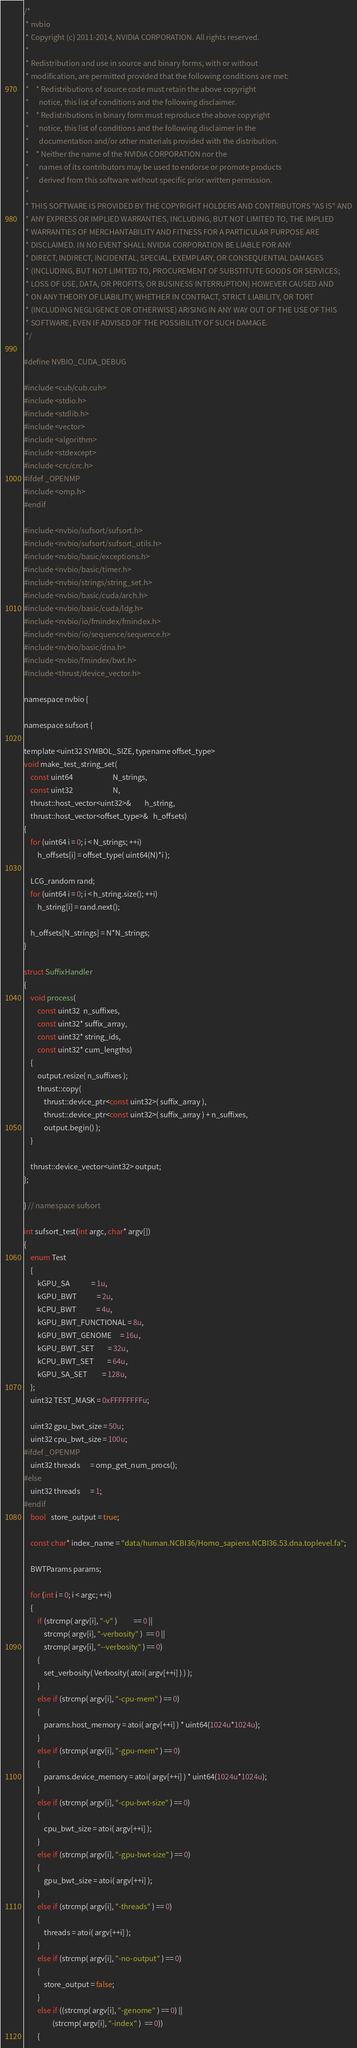Convert code to text. <code><loc_0><loc_0><loc_500><loc_500><_Cuda_>/*
 * nvbio
 * Copyright (c) 2011-2014, NVIDIA CORPORATION. All rights reserved.
 * 
 * Redistribution and use in source and binary forms, with or without
 * modification, are permitted provided that the following conditions are met:
 *    * Redistributions of source code must retain the above copyright
 *      notice, this list of conditions and the following disclaimer.
 *    * Redistributions in binary form must reproduce the above copyright
 *      notice, this list of conditions and the following disclaimer in the
 *      documentation and/or other materials provided with the distribution.
 *    * Neither the name of the NVIDIA CORPORATION nor the
 *      names of its contributors may be used to endorse or promote products
 *      derived from this software without specific prior written permission.
 * 
 * THIS SOFTWARE IS PROVIDED BY THE COPYRIGHT HOLDERS AND CONTRIBUTORS "AS IS" AND
 * ANY EXPRESS OR IMPLIED WARRANTIES, INCLUDING, BUT NOT LIMITED TO, THE IMPLIED
 * WARRANTIES OF MERCHANTABILITY AND FITNESS FOR A PARTICULAR PURPOSE ARE
 * DISCLAIMED. IN NO EVENT SHALL NVIDIA CORPORATION BE LIABLE FOR ANY
 * DIRECT, INDIRECT, INCIDENTAL, SPECIAL, EXEMPLARY, OR CONSEQUENTIAL DAMAGES
 * (INCLUDING, BUT NOT LIMITED TO, PROCUREMENT OF SUBSTITUTE GOODS OR SERVICES;
 * LOSS OF USE, DATA, OR PROFITS; OR BUSINESS INTERRUPTION) HOWEVER CAUSED AND
 * ON ANY THEORY OF LIABILITY, WHETHER IN CONTRACT, STRICT LIABILITY, OR TORT
 * (INCLUDING NEGLIGENCE OR OTHERWISE) ARISING IN ANY WAY OUT OF THE USE OF THIS
 * SOFTWARE, EVEN IF ADVISED OF THE POSSIBILITY OF SUCH DAMAGE.
 */

#define NVBIO_CUDA_DEBUG

#include <cub/cub.cuh>
#include <stdio.h>
#include <stdlib.h>
#include <vector>
#include <algorithm>
#include <stdexcept>
#include <crc/crc.h>
#ifdef _OPENMP
#include <omp.h>
#endif

#include <nvbio/sufsort/sufsort.h>
#include <nvbio/sufsort/sufsort_utils.h>
#include <nvbio/basic/exceptions.h>
#include <nvbio/basic/timer.h>
#include <nvbio/strings/string_set.h>
#include <nvbio/basic/cuda/arch.h>
#include <nvbio/basic/cuda/ldg.h>
#include <nvbio/io/fmindex/fmindex.h>
#include <nvbio/io/sequence/sequence.h>
#include <nvbio/basic/dna.h>
#include <nvbio/fmindex/bwt.h>
#include <thrust/device_vector.h>

namespace nvbio {

namespace sufsort {

template <uint32 SYMBOL_SIZE, typename offset_type>
void make_test_string_set(
    const uint64                        N_strings,
    const uint32                        N,
    thrust::host_vector<uint32>&        h_string,
    thrust::host_vector<offset_type>&   h_offsets)
{
    for (uint64 i = 0; i < N_strings; ++i)
        h_offsets[i] = offset_type( uint64(N)*i );

    LCG_random rand;
    for (uint64 i = 0; i < h_string.size(); ++i)
        h_string[i] = rand.next();

    h_offsets[N_strings] = N*N_strings;
}

struct SuffixHandler
{
    void process(
        const uint32  n_suffixes,
        const uint32* suffix_array,
        const uint32* string_ids,
        const uint32* cum_lengths)
    {
        output.resize( n_suffixes );
        thrust::copy(
            thrust::device_ptr<const uint32>( suffix_array ),
            thrust::device_ptr<const uint32>( suffix_array ) + n_suffixes,
            output.begin() );
    }

    thrust::device_vector<uint32> output;
};

} // namespace sufsort

int sufsort_test(int argc, char* argv[])
{
    enum Test
    {
        kGPU_SA             = 1u,
        kGPU_BWT            = 2u,
        kCPU_BWT            = 4u,
        kGPU_BWT_FUNCTIONAL = 8u,
        kGPU_BWT_GENOME     = 16u,
        kGPU_BWT_SET        = 32u,
        kCPU_BWT_SET        = 64u,
        kGPU_SA_SET         = 128u,
    };
    uint32 TEST_MASK = 0xFFFFFFFFu;

    uint32 gpu_bwt_size = 50u;
    uint32 cpu_bwt_size = 100u;
#ifdef _OPENMP
    uint32 threads      = omp_get_num_procs();
#else
    uint32 threads      = 1;
#endif
    bool   store_output = true;

    const char* index_name = "data/human.NCBI36/Homo_sapiens.NCBI36.53.dna.toplevel.fa";

    BWTParams params;

    for (int i = 0; i < argc; ++i)
    {
        if (strcmp( argv[i], "-v" )          == 0 ||
            strcmp( argv[i], "-verbosity" )  == 0 ||
            strcmp( argv[i], "--verbosity" ) == 0)
        {
            set_verbosity( Verbosity( atoi( argv[++i] ) ) );
        }
        else if (strcmp( argv[i], "-cpu-mem" ) == 0)
        {
            params.host_memory = atoi( argv[++i] ) * uint64(1024u*1024u);
        }
        else if (strcmp( argv[i], "-gpu-mem" ) == 0)
        {
            params.device_memory = atoi( argv[++i] ) * uint64(1024u*1024u);
        }
        else if (strcmp( argv[i], "-cpu-bwt-size" ) == 0)
        {
            cpu_bwt_size = atoi( argv[++i] );
        }
        else if (strcmp( argv[i], "-gpu-bwt-size" ) == 0)
        {
            gpu_bwt_size = atoi( argv[++i] );
        }
        else if (strcmp( argv[i], "-threads" ) == 0)
        {
            threads = atoi( argv[++i] );
        }
        else if (strcmp( argv[i], "-no-output" ) == 0)
        {
            store_output = false;
        }
        else if ((strcmp( argv[i], "-genome" ) == 0) ||
                 (strcmp( argv[i], "-index" )  == 0))
        {</code> 